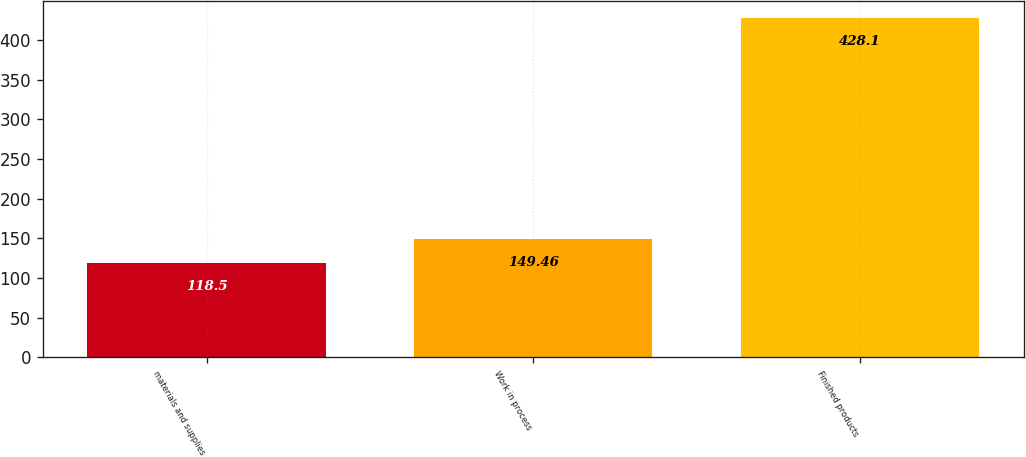Convert chart. <chart><loc_0><loc_0><loc_500><loc_500><bar_chart><fcel>materials and supplies<fcel>Work in process<fcel>Finished products<nl><fcel>118.5<fcel>149.46<fcel>428.1<nl></chart> 